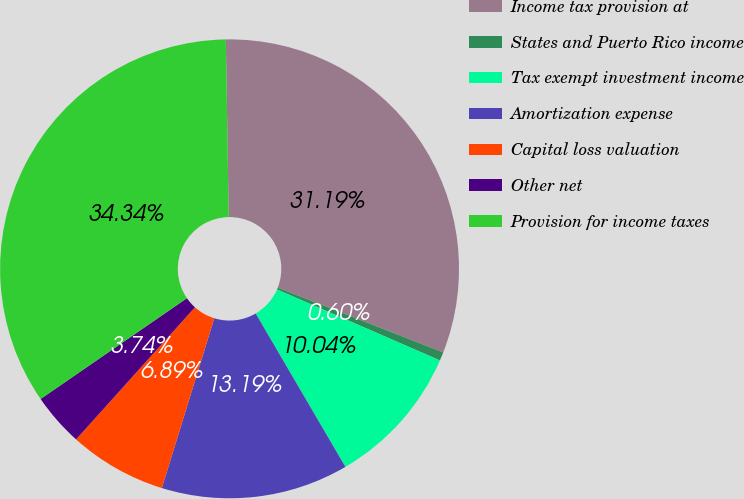Convert chart. <chart><loc_0><loc_0><loc_500><loc_500><pie_chart><fcel>Income tax provision at<fcel>States and Puerto Rico income<fcel>Tax exempt investment income<fcel>Amortization expense<fcel>Capital loss valuation<fcel>Other net<fcel>Provision for income taxes<nl><fcel>31.19%<fcel>0.6%<fcel>10.04%<fcel>13.19%<fcel>6.89%<fcel>3.74%<fcel>34.34%<nl></chart> 